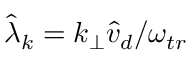Convert formula to latex. <formula><loc_0><loc_0><loc_500><loc_500>\hat { \lambda } _ { k } = k _ { \perp } \hat { v } _ { d } / \omega _ { t r }</formula> 